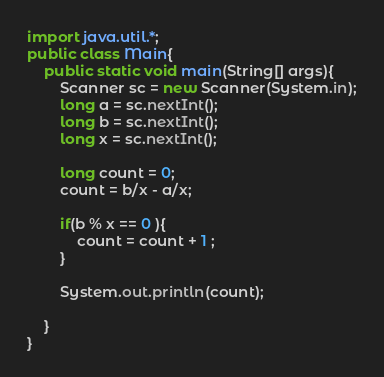Convert code to text. <code><loc_0><loc_0><loc_500><loc_500><_Java_>import java.util.*;
public class Main{
	public static void main(String[] args){
		Scanner sc = new Scanner(System.in);
		long a = sc.nextInt();
		long b = sc.nextInt();
		long x = sc.nextInt();

		long count = 0;
		count = b/x - a/x;

		if(b % x == 0 ){
			count = count + 1 ;
		}

		System.out.println(count);

	}
}</code> 